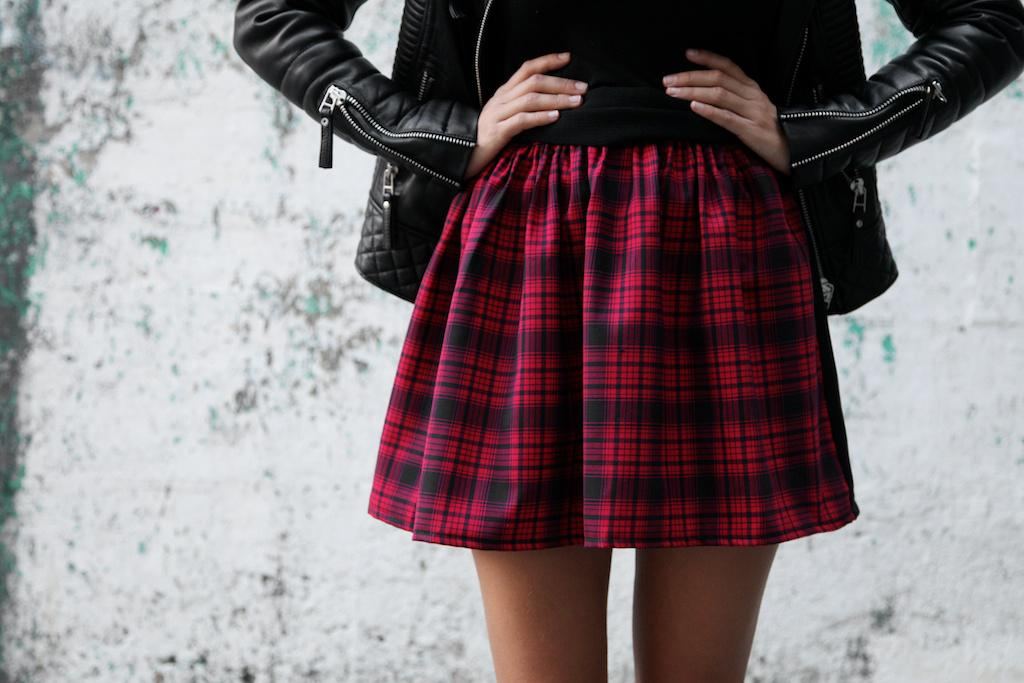What is the main subject of the image? There is a person standing in the image. What is the person wearing? The person is wearing a black jacket. Can you describe the background of the image? The background of the image is blurred. What can be seen in the background of the image? There is a well in the background of the image. What type of test can be seen being conducted in the image? There is no test being conducted in the image; it features a person standing with a blurred background and a well in the background. What type of bird is perched on the person's shoulder in the image? There is no bird present in the image. 